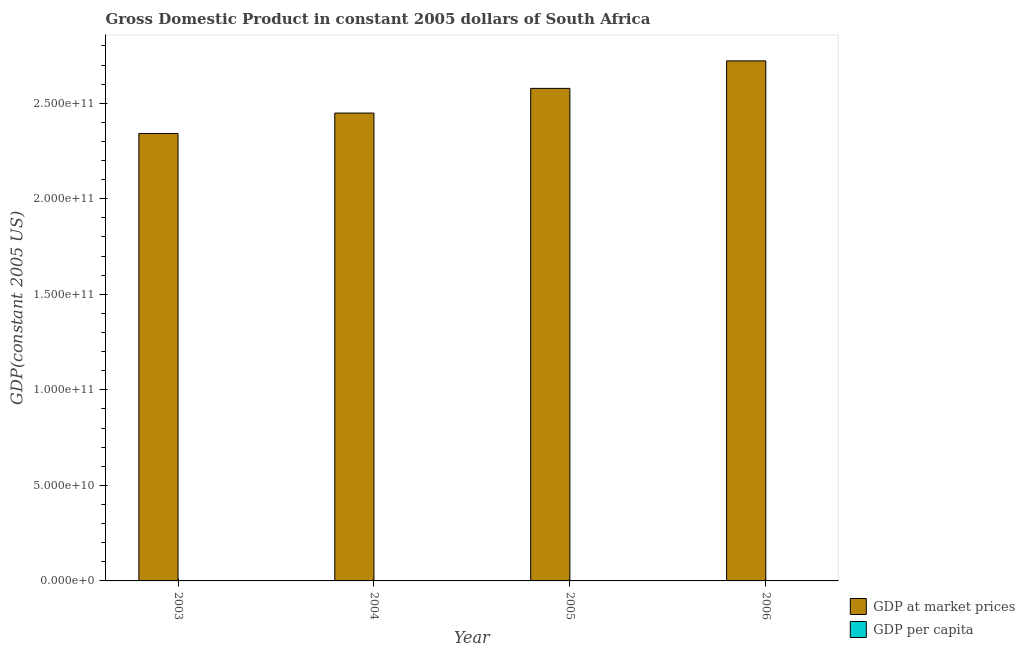Are the number of bars per tick equal to the number of legend labels?
Your response must be concise. Yes. How many bars are there on the 4th tick from the left?
Keep it short and to the point. 2. What is the gdp at market prices in 2005?
Your answer should be very brief. 2.58e+11. Across all years, what is the maximum gdp at market prices?
Ensure brevity in your answer.  2.72e+11. Across all years, what is the minimum gdp per capita?
Ensure brevity in your answer.  5076.95. What is the total gdp per capita in the graph?
Ensure brevity in your answer.  2.14e+04. What is the difference between the gdp at market prices in 2004 and that in 2005?
Give a very brief answer. -1.29e+1. What is the difference between the gdp at market prices in 2005 and the gdp per capita in 2006?
Your answer should be very brief. -1.44e+1. What is the average gdp at market prices per year?
Your response must be concise. 2.52e+11. What is the ratio of the gdp at market prices in 2004 to that in 2006?
Keep it short and to the point. 0.9. Is the difference between the gdp at market prices in 2004 and 2006 greater than the difference between the gdp per capita in 2004 and 2006?
Keep it short and to the point. No. What is the difference between the highest and the second highest gdp per capita?
Ensure brevity in your answer.  227.08. What is the difference between the highest and the lowest gdp at market prices?
Provide a short and direct response. 3.80e+1. In how many years, is the gdp per capita greater than the average gdp per capita taken over all years?
Ensure brevity in your answer.  2. What does the 2nd bar from the left in 2003 represents?
Ensure brevity in your answer.  GDP per capita. What does the 2nd bar from the right in 2006 represents?
Your answer should be compact. GDP at market prices. Are all the bars in the graph horizontal?
Give a very brief answer. No. Are the values on the major ticks of Y-axis written in scientific E-notation?
Your answer should be very brief. Yes. How are the legend labels stacked?
Make the answer very short. Vertical. What is the title of the graph?
Make the answer very short. Gross Domestic Product in constant 2005 dollars of South Africa. Does "Canada" appear as one of the legend labels in the graph?
Your response must be concise. No. What is the label or title of the X-axis?
Offer a very short reply. Year. What is the label or title of the Y-axis?
Provide a short and direct response. GDP(constant 2005 US). What is the GDP(constant 2005 US) in GDP at market prices in 2003?
Make the answer very short. 2.34e+11. What is the GDP(constant 2005 US) in GDP per capita in 2003?
Your answer should be very brief. 5076.95. What is the GDP(constant 2005 US) of GDP at market prices in 2004?
Offer a terse response. 2.45e+11. What is the GDP(constant 2005 US) in GDP per capita in 2004?
Your answer should be very brief. 5239.95. What is the GDP(constant 2005 US) in GDP at market prices in 2005?
Your answer should be very brief. 2.58e+11. What is the GDP(constant 2005 US) in GDP per capita in 2005?
Provide a short and direct response. 5444.08. What is the GDP(constant 2005 US) of GDP at market prices in 2006?
Keep it short and to the point. 2.72e+11. What is the GDP(constant 2005 US) of GDP per capita in 2006?
Give a very brief answer. 5671.15. Across all years, what is the maximum GDP(constant 2005 US) in GDP at market prices?
Make the answer very short. 2.72e+11. Across all years, what is the maximum GDP(constant 2005 US) of GDP per capita?
Offer a terse response. 5671.15. Across all years, what is the minimum GDP(constant 2005 US) in GDP at market prices?
Provide a short and direct response. 2.34e+11. Across all years, what is the minimum GDP(constant 2005 US) of GDP per capita?
Your response must be concise. 5076.95. What is the total GDP(constant 2005 US) of GDP at market prices in the graph?
Provide a short and direct response. 1.01e+12. What is the total GDP(constant 2005 US) in GDP per capita in the graph?
Your answer should be very brief. 2.14e+04. What is the difference between the GDP(constant 2005 US) in GDP at market prices in 2003 and that in 2004?
Your answer should be very brief. -1.07e+1. What is the difference between the GDP(constant 2005 US) of GDP per capita in 2003 and that in 2004?
Give a very brief answer. -163. What is the difference between the GDP(constant 2005 US) of GDP at market prices in 2003 and that in 2005?
Ensure brevity in your answer.  -2.36e+1. What is the difference between the GDP(constant 2005 US) in GDP per capita in 2003 and that in 2005?
Keep it short and to the point. -367.13. What is the difference between the GDP(constant 2005 US) of GDP at market prices in 2003 and that in 2006?
Make the answer very short. -3.80e+1. What is the difference between the GDP(constant 2005 US) in GDP per capita in 2003 and that in 2006?
Give a very brief answer. -594.2. What is the difference between the GDP(constant 2005 US) in GDP at market prices in 2004 and that in 2005?
Your answer should be compact. -1.29e+1. What is the difference between the GDP(constant 2005 US) of GDP per capita in 2004 and that in 2005?
Offer a very short reply. -204.13. What is the difference between the GDP(constant 2005 US) of GDP at market prices in 2004 and that in 2006?
Offer a very short reply. -2.73e+1. What is the difference between the GDP(constant 2005 US) in GDP per capita in 2004 and that in 2006?
Provide a short and direct response. -431.2. What is the difference between the GDP(constant 2005 US) in GDP at market prices in 2005 and that in 2006?
Your response must be concise. -1.44e+1. What is the difference between the GDP(constant 2005 US) in GDP per capita in 2005 and that in 2006?
Give a very brief answer. -227.08. What is the difference between the GDP(constant 2005 US) of GDP at market prices in 2003 and the GDP(constant 2005 US) of GDP per capita in 2004?
Your response must be concise. 2.34e+11. What is the difference between the GDP(constant 2005 US) in GDP at market prices in 2003 and the GDP(constant 2005 US) in GDP per capita in 2005?
Your answer should be very brief. 2.34e+11. What is the difference between the GDP(constant 2005 US) in GDP at market prices in 2003 and the GDP(constant 2005 US) in GDP per capita in 2006?
Provide a succinct answer. 2.34e+11. What is the difference between the GDP(constant 2005 US) of GDP at market prices in 2004 and the GDP(constant 2005 US) of GDP per capita in 2005?
Your answer should be compact. 2.45e+11. What is the difference between the GDP(constant 2005 US) of GDP at market prices in 2004 and the GDP(constant 2005 US) of GDP per capita in 2006?
Keep it short and to the point. 2.45e+11. What is the difference between the GDP(constant 2005 US) in GDP at market prices in 2005 and the GDP(constant 2005 US) in GDP per capita in 2006?
Keep it short and to the point. 2.58e+11. What is the average GDP(constant 2005 US) in GDP at market prices per year?
Ensure brevity in your answer.  2.52e+11. What is the average GDP(constant 2005 US) in GDP per capita per year?
Ensure brevity in your answer.  5358.03. In the year 2003, what is the difference between the GDP(constant 2005 US) in GDP at market prices and GDP(constant 2005 US) in GDP per capita?
Your answer should be compact. 2.34e+11. In the year 2004, what is the difference between the GDP(constant 2005 US) in GDP at market prices and GDP(constant 2005 US) in GDP per capita?
Give a very brief answer. 2.45e+11. In the year 2005, what is the difference between the GDP(constant 2005 US) in GDP at market prices and GDP(constant 2005 US) in GDP per capita?
Your response must be concise. 2.58e+11. In the year 2006, what is the difference between the GDP(constant 2005 US) in GDP at market prices and GDP(constant 2005 US) in GDP per capita?
Offer a terse response. 2.72e+11. What is the ratio of the GDP(constant 2005 US) in GDP at market prices in 2003 to that in 2004?
Your response must be concise. 0.96. What is the ratio of the GDP(constant 2005 US) in GDP per capita in 2003 to that in 2004?
Give a very brief answer. 0.97. What is the ratio of the GDP(constant 2005 US) in GDP at market prices in 2003 to that in 2005?
Keep it short and to the point. 0.91. What is the ratio of the GDP(constant 2005 US) in GDP per capita in 2003 to that in 2005?
Provide a succinct answer. 0.93. What is the ratio of the GDP(constant 2005 US) in GDP at market prices in 2003 to that in 2006?
Your answer should be compact. 0.86. What is the ratio of the GDP(constant 2005 US) of GDP per capita in 2003 to that in 2006?
Provide a short and direct response. 0.9. What is the ratio of the GDP(constant 2005 US) in GDP at market prices in 2004 to that in 2005?
Your answer should be compact. 0.95. What is the ratio of the GDP(constant 2005 US) of GDP per capita in 2004 to that in 2005?
Offer a very short reply. 0.96. What is the ratio of the GDP(constant 2005 US) of GDP at market prices in 2004 to that in 2006?
Give a very brief answer. 0.9. What is the ratio of the GDP(constant 2005 US) of GDP per capita in 2004 to that in 2006?
Provide a succinct answer. 0.92. What is the ratio of the GDP(constant 2005 US) in GDP at market prices in 2005 to that in 2006?
Keep it short and to the point. 0.95. What is the difference between the highest and the second highest GDP(constant 2005 US) in GDP at market prices?
Keep it short and to the point. 1.44e+1. What is the difference between the highest and the second highest GDP(constant 2005 US) of GDP per capita?
Offer a very short reply. 227.08. What is the difference between the highest and the lowest GDP(constant 2005 US) in GDP at market prices?
Ensure brevity in your answer.  3.80e+1. What is the difference between the highest and the lowest GDP(constant 2005 US) of GDP per capita?
Ensure brevity in your answer.  594.2. 